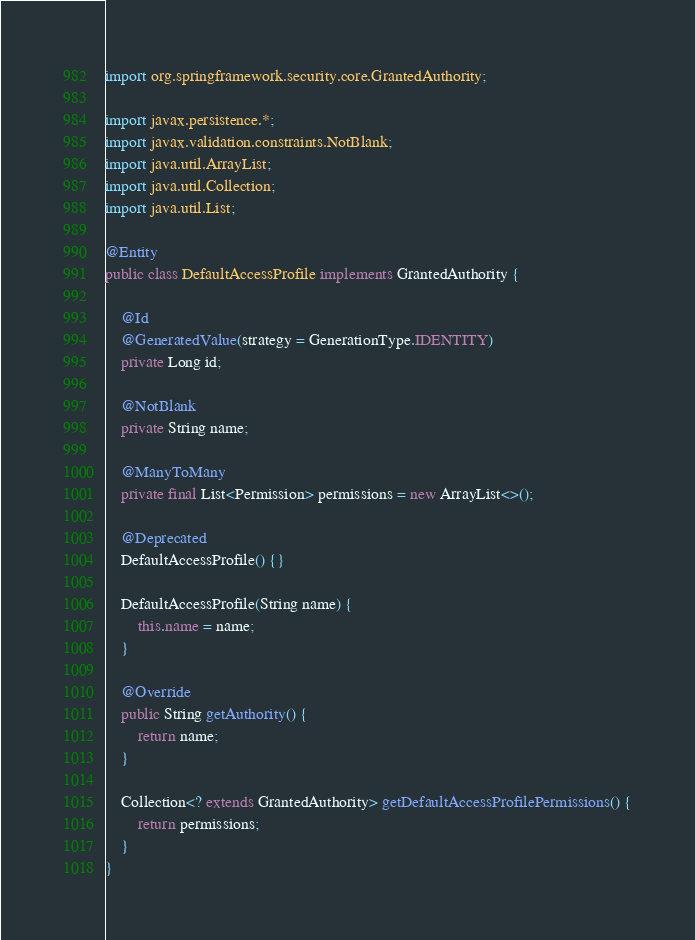<code> <loc_0><loc_0><loc_500><loc_500><_Java_>import org.springframework.security.core.GrantedAuthority;

import javax.persistence.*;
import javax.validation.constraints.NotBlank;
import java.util.ArrayList;
import java.util.Collection;
import java.util.List;

@Entity
public class DefaultAccessProfile implements GrantedAuthority {

    @Id
    @GeneratedValue(strategy = GenerationType.IDENTITY)
    private Long id;

    @NotBlank
    private String name;

    @ManyToMany
    private final List<Permission> permissions = new ArrayList<>();

    @Deprecated
    DefaultAccessProfile() {}

    DefaultAccessProfile(String name) {
        this.name = name;
    }

    @Override
    public String getAuthority() {
        return name;
    }

    Collection<? extends GrantedAuthority> getDefaultAccessProfilePermissions() {
        return permissions;
    }
}
</code> 